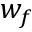Convert formula to latex. <formula><loc_0><loc_0><loc_500><loc_500>w _ { f }</formula> 